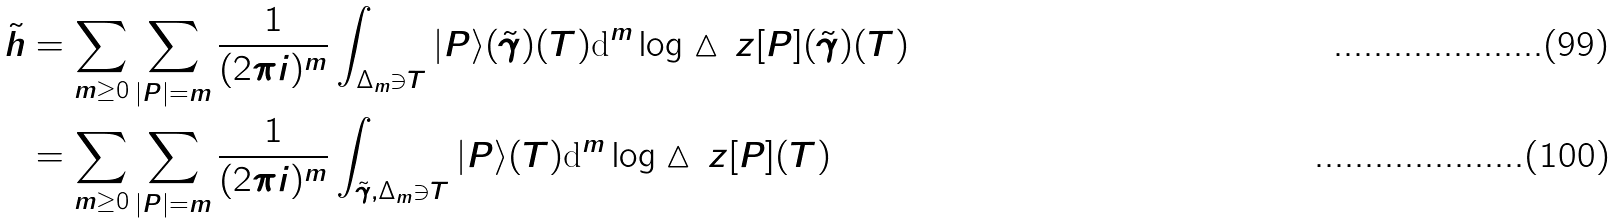<formula> <loc_0><loc_0><loc_500><loc_500>\tilde { h } & = \sum _ { m \geq 0 } \sum _ { | P | = m } \frac { 1 } { ( 2 \pi i ) ^ { m } } \int _ { \Delta _ { m } \ni T } | P \rangle ( \tilde { \gamma } ) ( T ) \text {d} ^ { m } \log \vartriangle \, z [ P ] ( \tilde { \gamma } ) ( T ) \\ & = \sum _ { m \geq 0 } \sum _ { | P | = m } \frac { 1 } { ( 2 \pi i ) ^ { m } } \int _ { \tilde { \gamma } , \Delta _ { m } \ni T } | P \rangle ( T ) \text {d} ^ { m } \log \vartriangle \, z [ P ] ( T )</formula> 